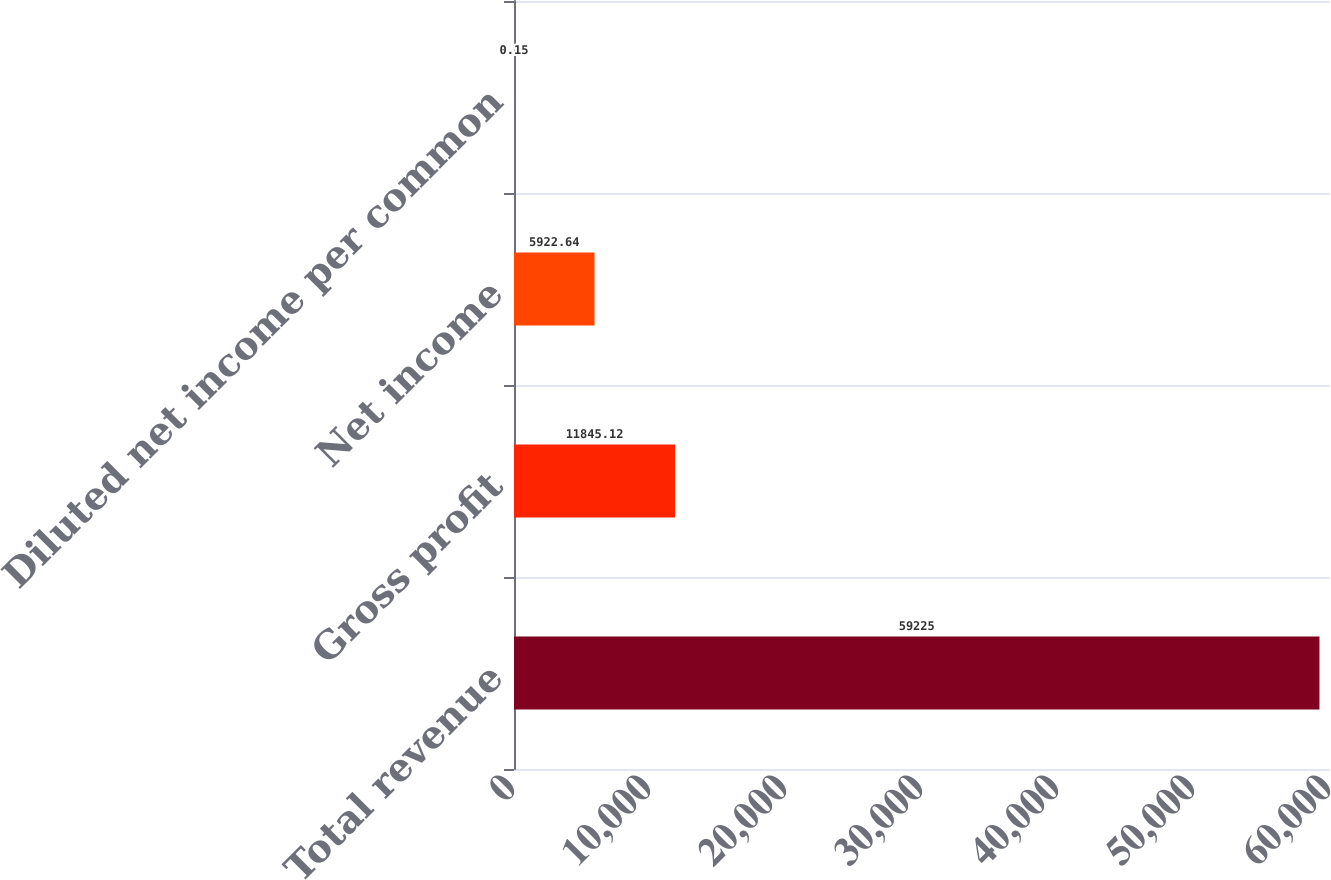<chart> <loc_0><loc_0><loc_500><loc_500><bar_chart><fcel>Total revenue<fcel>Gross profit<fcel>Net income<fcel>Diluted net income per common<nl><fcel>59225<fcel>11845.1<fcel>5922.64<fcel>0.15<nl></chart> 